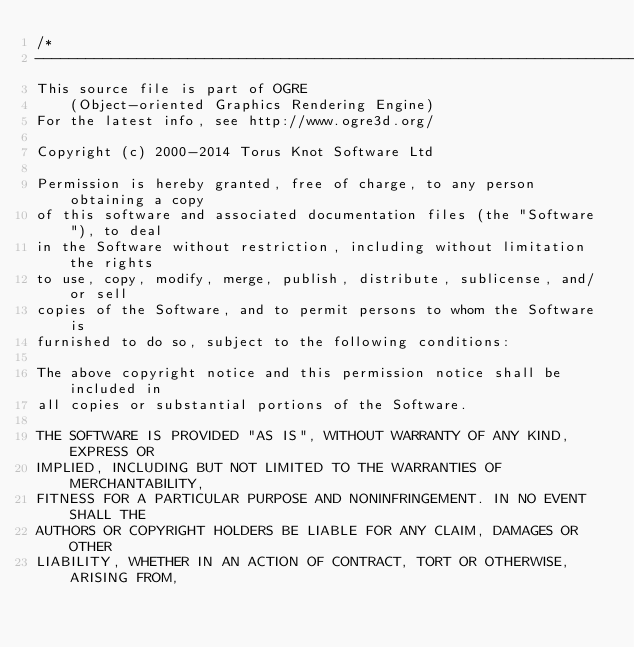<code> <loc_0><loc_0><loc_500><loc_500><_C++_>/*
-----------------------------------------------------------------------------
This source file is part of OGRE
    (Object-oriented Graphics Rendering Engine)
For the latest info, see http://www.ogre3d.org/

Copyright (c) 2000-2014 Torus Knot Software Ltd

Permission is hereby granted, free of charge, to any person obtaining a copy
of this software and associated documentation files (the "Software"), to deal
in the Software without restriction, including without limitation the rights
to use, copy, modify, merge, publish, distribute, sublicense, and/or sell
copies of the Software, and to permit persons to whom the Software is
furnished to do so, subject to the following conditions:

The above copyright notice and this permission notice shall be included in
all copies or substantial portions of the Software.

THE SOFTWARE IS PROVIDED "AS IS", WITHOUT WARRANTY OF ANY KIND, EXPRESS OR
IMPLIED, INCLUDING BUT NOT LIMITED TO THE WARRANTIES OF MERCHANTABILITY,
FITNESS FOR A PARTICULAR PURPOSE AND NONINFRINGEMENT. IN NO EVENT SHALL THE
AUTHORS OR COPYRIGHT HOLDERS BE LIABLE FOR ANY CLAIM, DAMAGES OR OTHER
LIABILITY, WHETHER IN AN ACTION OF CONTRACT, TORT OR OTHERWISE, ARISING FROM,</code> 